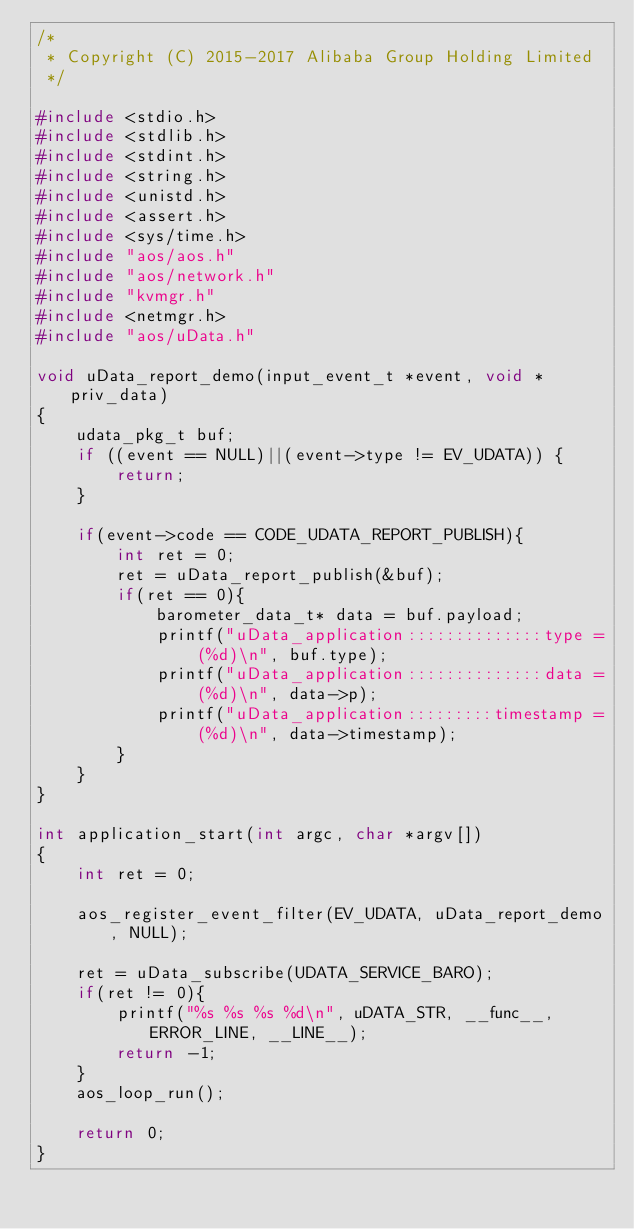<code> <loc_0><loc_0><loc_500><loc_500><_C_>/*
 * Copyright (C) 2015-2017 Alibaba Group Holding Limited
 */

#include <stdio.h>
#include <stdlib.h>
#include <stdint.h>
#include <string.h>
#include <unistd.h>
#include <assert.h>
#include <sys/time.h>
#include "aos/aos.h"
#include "aos/network.h"
#include "kvmgr.h"
#include <netmgr.h>
#include "aos/uData.h"

void uData_report_demo(input_event_t *event, void *priv_data)
{
    udata_pkg_t buf;
    if ((event == NULL)||(event->type != EV_UDATA)) {
        return;
    }
    
    if(event->code == CODE_UDATA_REPORT_PUBLISH){
        int ret = 0;
        ret = uData_report_publish(&buf);
        if(ret == 0){
            barometer_data_t* data = buf.payload;
            printf("uData_application::::::::::::::type = (%d)\n", buf.type);
            printf("uData_application::::::::::::::data = (%d)\n", data->p);
            printf("uData_application:::::::::timestamp = (%d)\n", data->timestamp);
        }
    }
}

int application_start(int argc, char *argv[])
{
    int ret = 0;
    
    aos_register_event_filter(EV_UDATA, uData_report_demo, NULL);

    ret = uData_subscribe(UDATA_SERVICE_BARO);
    if(ret != 0){
        printf("%s %s %s %d\n", uDATA_STR, __func__, ERROR_LINE, __LINE__);
        return -1;
    }
    aos_loop_run();

    return 0;
}
</code> 